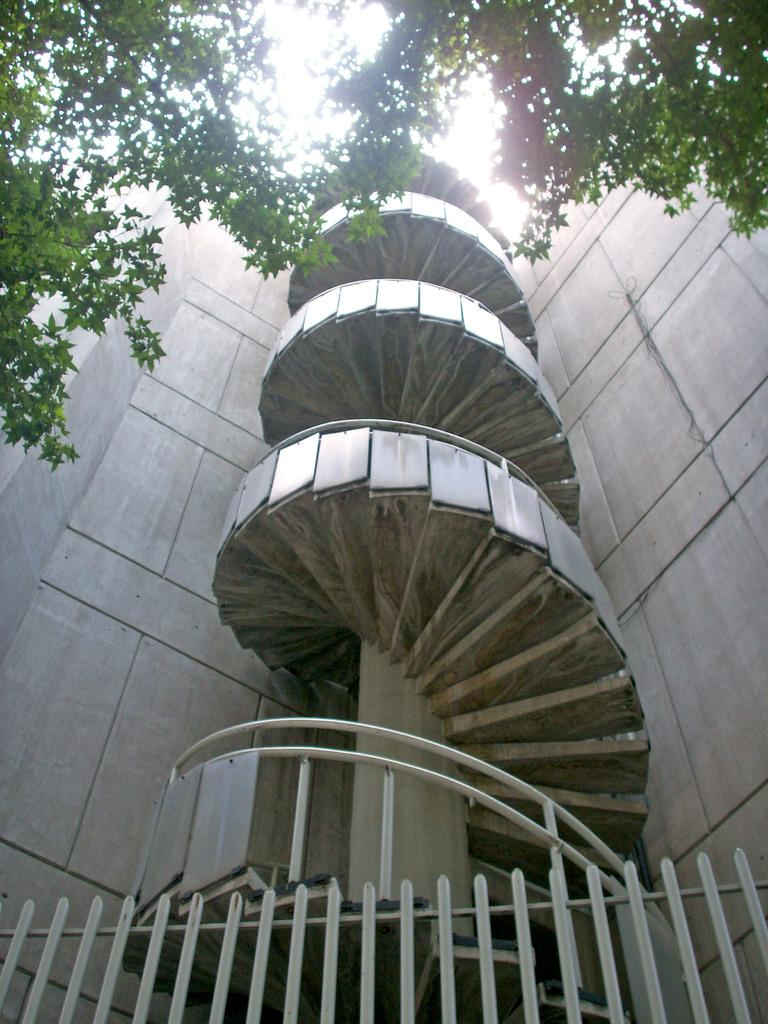What type of structure is visible in the image? There is a building in the image. What feature of the building is mentioned in the facts? The building has stairs. What other objects or elements can be seen in the image? There are trees and iron grilles present in the image. What can be seen in the background of the image? The sky is visible in the background of the image. What type of nerve can be seen in the image? There is no nerve present in the image; it features a building with stairs, trees, iron grilles, and a visible sky. 